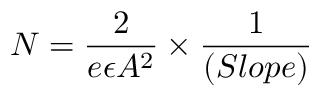Convert formula to latex. <formula><loc_0><loc_0><loc_500><loc_500>N = \frac { 2 } { e \epsilon A ^ { 2 } } \times \frac { 1 } { ( S l o p e ) }</formula> 